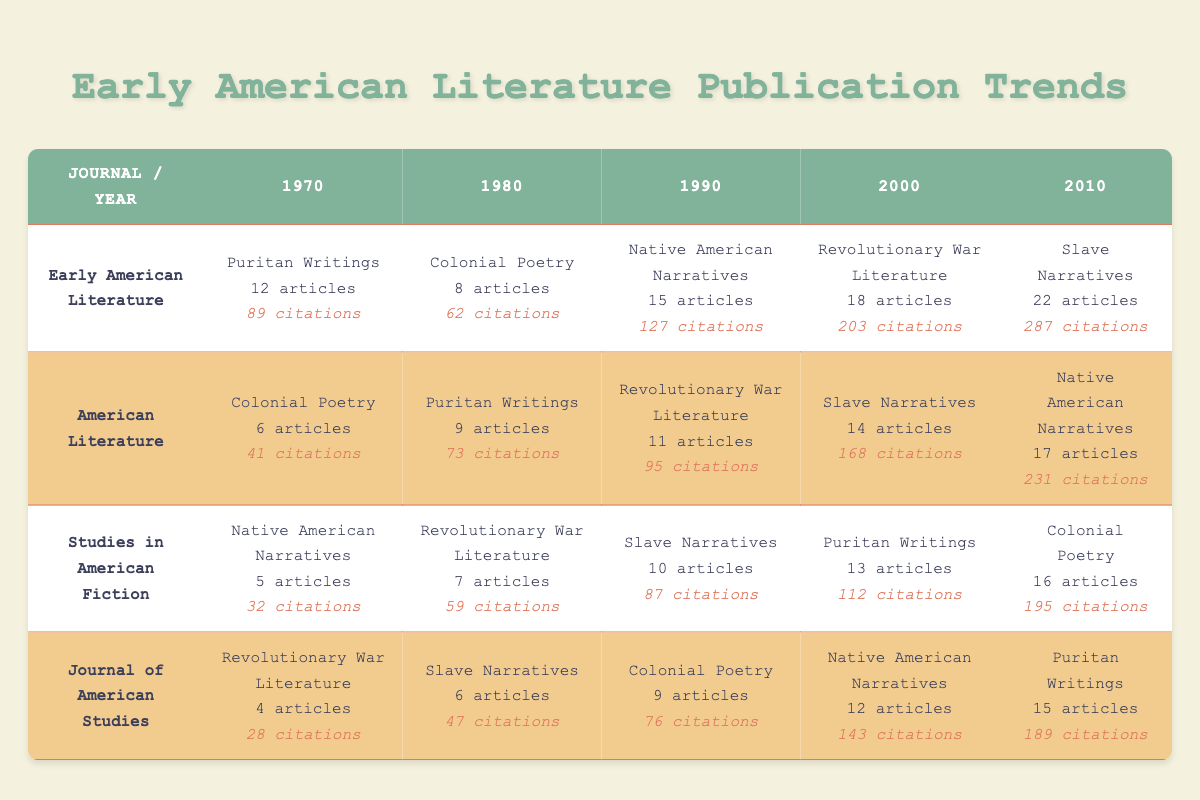What is the total number of articles published on Slave Narratives across all journals in 2010? In 2010, the articles on Slave Narratives were as follows: Early American Literature (22), American Literature (14), Studies in American Fiction (16), and Journal of American Studies (6). Adding these gives 22 + 14 + 16 + 6 = 58 articles.
Answer: 58 Which journal had the highest number of articles published in 2000? In 2000, the number of articles published was: Early American Literature (18), American Literature (14), Studies in American Fiction (13), and Journal of American Studies (12). The highest among these is 18 articles from Early American Literature.
Answer: Early American Literature True or False: The number of articles published on Native American Narratives in 1990 exceeded those published in 2000. In 1990, Early American Literature published 15 articles on Native American Narratives, while in 2000, Journal of American Studies published only 12 articles on the same topic. Since 15 > 12, the statement is true.
Answer: True What was the average number of citations for Colonial Poetry articles across all journals in 1980? In 1980, the citations for Colonial Poetry articles were: Early American Literature (62), American Literature (41), Studies in American Fiction (N/A), and Journal of American Studies (76). The relevant journals are 3. Adding these is 62 + 41 + 76 = 179. The average then is 179/3 = 59.67.
Answer: 59.67 Which decade had the maximum total citations for Slave Narratives? The total citations for Slave Narratives in each decade are: 1990 (87), 2000 (168), and 2010 (287). Summing these gives: 87 + 168 + 287 = 542. Thus, the maximum total citations are from the 2010s with 287 citations.
Answer: 2010s What is the difference in the number of articles on Revolutionary War Literature published in 1990 compared to 2000? In 1990, the number of articles on Revolutionary War Literature was 11 (American Literature) and 7 (Studies in American Fiction), totaling 18. In 2000, it was 18 articles from Early American Literature only. Thus, the difference in published articles is 18 - 18 = 0.
Answer: 0 